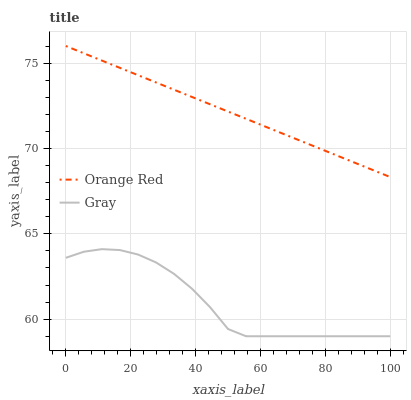Does Gray have the minimum area under the curve?
Answer yes or no. Yes. Does Orange Red have the maximum area under the curve?
Answer yes or no. Yes. Does Orange Red have the minimum area under the curve?
Answer yes or no. No. Is Orange Red the smoothest?
Answer yes or no. Yes. Is Gray the roughest?
Answer yes or no. Yes. Is Orange Red the roughest?
Answer yes or no. No. Does Gray have the lowest value?
Answer yes or no. Yes. Does Orange Red have the lowest value?
Answer yes or no. No. Does Orange Red have the highest value?
Answer yes or no. Yes. Is Gray less than Orange Red?
Answer yes or no. Yes. Is Orange Red greater than Gray?
Answer yes or no. Yes. Does Gray intersect Orange Red?
Answer yes or no. No. 